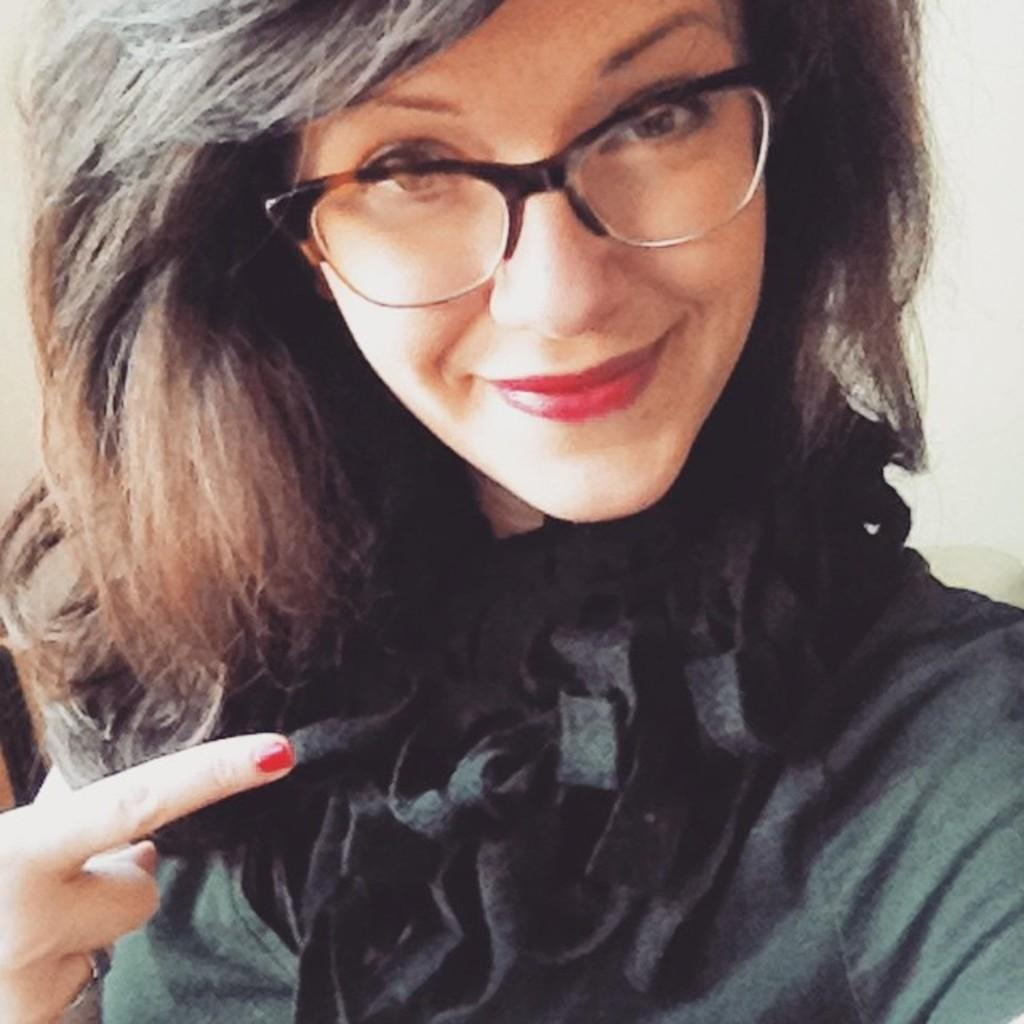What is the main subject of the image? There is a woman in the image. What type of quilt is being used to create the smoke in the image? There is no quilt or smoke present in the image; it only features a woman. 